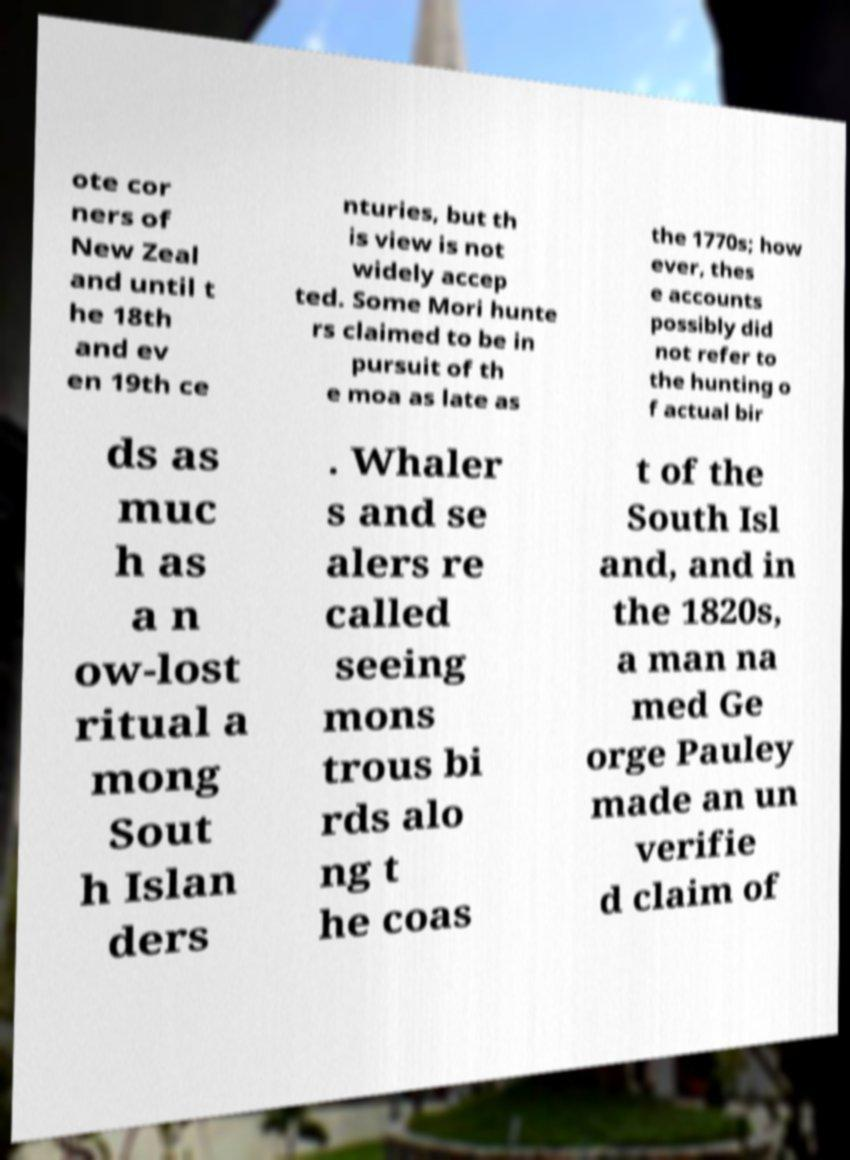There's text embedded in this image that I need extracted. Can you transcribe it verbatim? ote cor ners of New Zeal and until t he 18th and ev en 19th ce nturies, but th is view is not widely accep ted. Some Mori hunte rs claimed to be in pursuit of th e moa as late as the 1770s; how ever, thes e accounts possibly did not refer to the hunting o f actual bir ds as muc h as a n ow-lost ritual a mong Sout h Islan ders . Whaler s and se alers re called seeing mons trous bi rds alo ng t he coas t of the South Isl and, and in the 1820s, a man na med Ge orge Pauley made an un verifie d claim of 